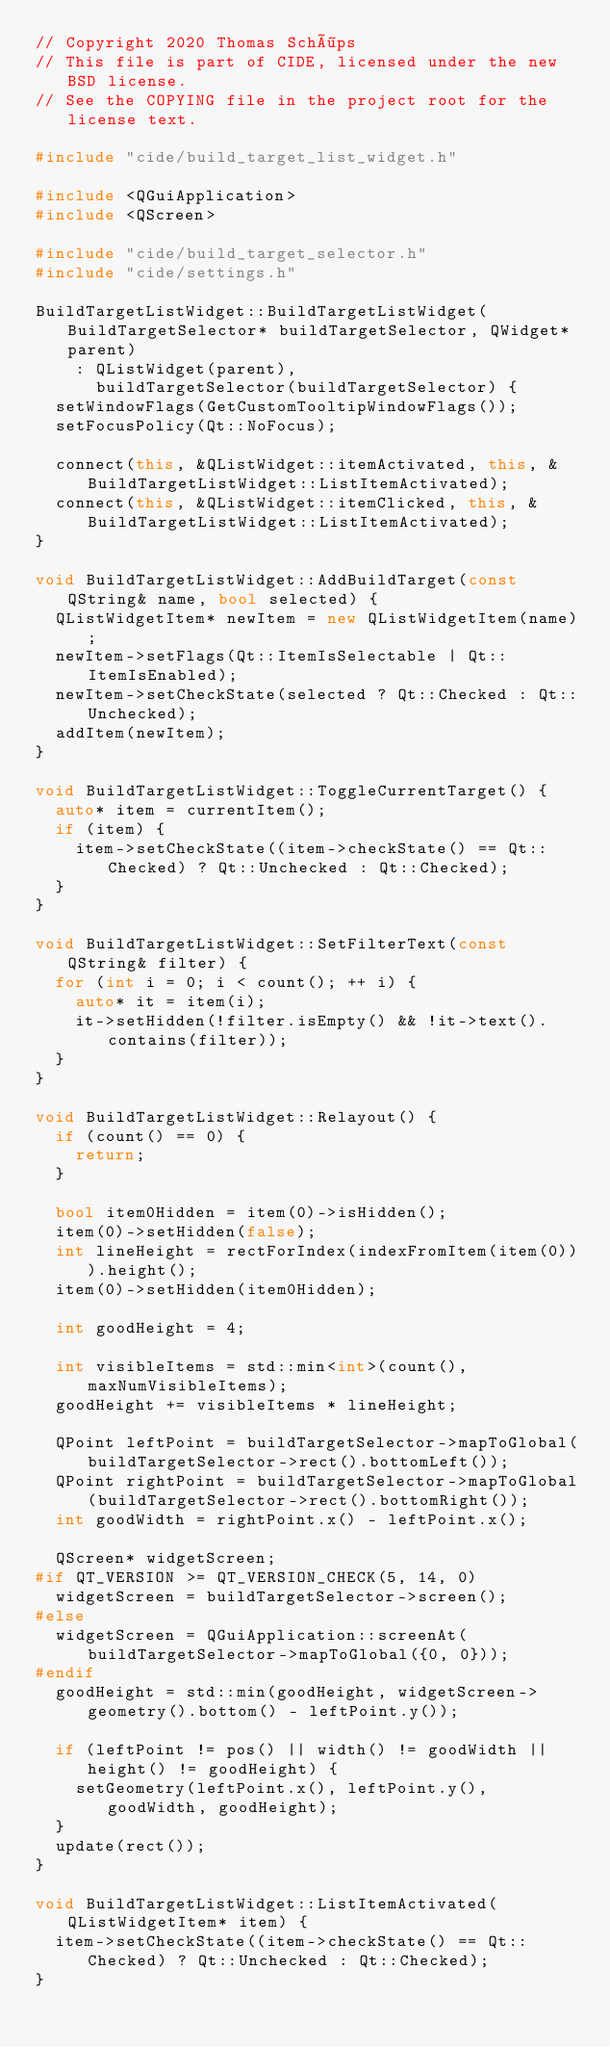Convert code to text. <code><loc_0><loc_0><loc_500><loc_500><_C++_>// Copyright 2020 Thomas Schöps
// This file is part of CIDE, licensed under the new BSD license.
// See the COPYING file in the project root for the license text.

#include "cide/build_target_list_widget.h"

#include <QGuiApplication>
#include <QScreen>

#include "cide/build_target_selector.h"
#include "cide/settings.h"

BuildTargetListWidget::BuildTargetListWidget(BuildTargetSelector* buildTargetSelector, QWidget* parent)
    : QListWidget(parent),
      buildTargetSelector(buildTargetSelector) {
  setWindowFlags(GetCustomTooltipWindowFlags());
  setFocusPolicy(Qt::NoFocus);
  
  connect(this, &QListWidget::itemActivated, this, &BuildTargetListWidget::ListItemActivated);
  connect(this, &QListWidget::itemClicked, this, &BuildTargetListWidget::ListItemActivated);
}

void BuildTargetListWidget::AddBuildTarget(const QString& name, bool selected) {
  QListWidgetItem* newItem = new QListWidgetItem(name);
  newItem->setFlags(Qt::ItemIsSelectable | Qt::ItemIsEnabled);
  newItem->setCheckState(selected ? Qt::Checked : Qt::Unchecked);
  addItem(newItem);
}

void BuildTargetListWidget::ToggleCurrentTarget() {
  auto* item = currentItem();
  if (item) {
    item->setCheckState((item->checkState() == Qt::Checked) ? Qt::Unchecked : Qt::Checked);
  }
}

void BuildTargetListWidget::SetFilterText(const QString& filter) {
  for (int i = 0; i < count(); ++ i) {
    auto* it = item(i);
    it->setHidden(!filter.isEmpty() && !it->text().contains(filter));
  }
}

void BuildTargetListWidget::Relayout() {
  if (count() == 0) {
    return;
  }
  
  bool item0Hidden = item(0)->isHidden();
  item(0)->setHidden(false);
  int lineHeight = rectForIndex(indexFromItem(item(0))).height();
  item(0)->setHidden(item0Hidden);
  
  int goodHeight = 4;
  
  int visibleItems = std::min<int>(count(), maxNumVisibleItems);
  goodHeight += visibleItems * lineHeight;
  
  QPoint leftPoint = buildTargetSelector->mapToGlobal(buildTargetSelector->rect().bottomLeft());
  QPoint rightPoint = buildTargetSelector->mapToGlobal(buildTargetSelector->rect().bottomRight());
  int goodWidth = rightPoint.x() - leftPoint.x();
  
  QScreen* widgetScreen;
#if QT_VERSION >= QT_VERSION_CHECK(5, 14, 0)
  widgetScreen = buildTargetSelector->screen();
#else
  widgetScreen = QGuiApplication::screenAt(buildTargetSelector->mapToGlobal({0, 0}));
#endif
  goodHeight = std::min(goodHeight, widgetScreen->geometry().bottom() - leftPoint.y());
  
  if (leftPoint != pos() || width() != goodWidth || height() != goodHeight) {
    setGeometry(leftPoint.x(), leftPoint.y(), goodWidth, goodHeight);
  }
  update(rect());
}

void BuildTargetListWidget::ListItemActivated(QListWidgetItem* item) {
  item->setCheckState((item->checkState() == Qt::Checked) ? Qt::Unchecked : Qt::Checked);
}
</code> 